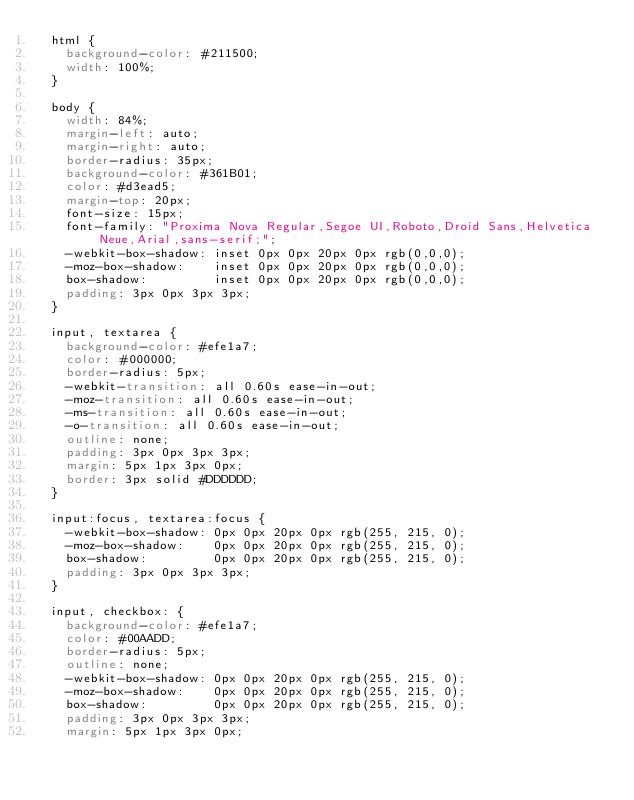<code> <loc_0><loc_0><loc_500><loc_500><_CSS_>  html {
    background-color: #211500;
    width: 100%;
  }

  body {
    width: 84%;
    margin-left: auto;
    margin-right: auto;
    border-radius: 35px;
    background-color: #361B01;
    color: #d3ead5;
    margin-top: 20px;
    font-size: 15px;
    font-family: "Proxima Nova Regular,Segoe UI,Roboto,Droid Sans,Helvetica Neue,Arial,sans-serif;";
    -webkit-box-shadow: inset 0px 0px 20px 0px rgb(0,0,0);
    -moz-box-shadow:    inset 0px 0px 20px 0px rgb(0,0,0);
    box-shadow:         inset 0px 0px 20px 0px rgb(0,0,0);
    padding: 3px 0px 3px 3px;
  }

  input, textarea {
    background-color: #efe1a7;
    color: #000000;
    border-radius: 5px;
    -webkit-transition: all 0.60s ease-in-out;
    -moz-transition: all 0.60s ease-in-out;
    -ms-transition: all 0.60s ease-in-out;
    -o-transition: all 0.60s ease-in-out;
    outline: none;
    padding: 3px 0px 3px 3px;
    margin: 5px 1px 3px 0px;
    border: 3px solid #DDDDDD;
  }

  input:focus, textarea:focus {
    -webkit-box-shadow: 0px 0px 20px 0px rgb(255, 215, 0);
    -moz-box-shadow:    0px 0px 20px 0px rgb(255, 215, 0);
    box-shadow:         0px 0px 20px 0px rgb(255, 215, 0);
    padding: 3px 0px 3px 3px;
  }

  input, checkbox: {
    background-color: #efe1a7;
    color: #00AADD;
    border-radius: 5px;
    outline: none;
    -webkit-box-shadow: 0px 0px 20px 0px rgb(255, 215, 0);
    -moz-box-shadow:    0px 0px 20px 0px rgb(255, 215, 0);
    box-shadow:         0px 0px 20px 0px rgb(255, 215, 0);
    padding: 3px 0px 3px 3px;
    margin: 5px 1px 3px 0px;</code> 